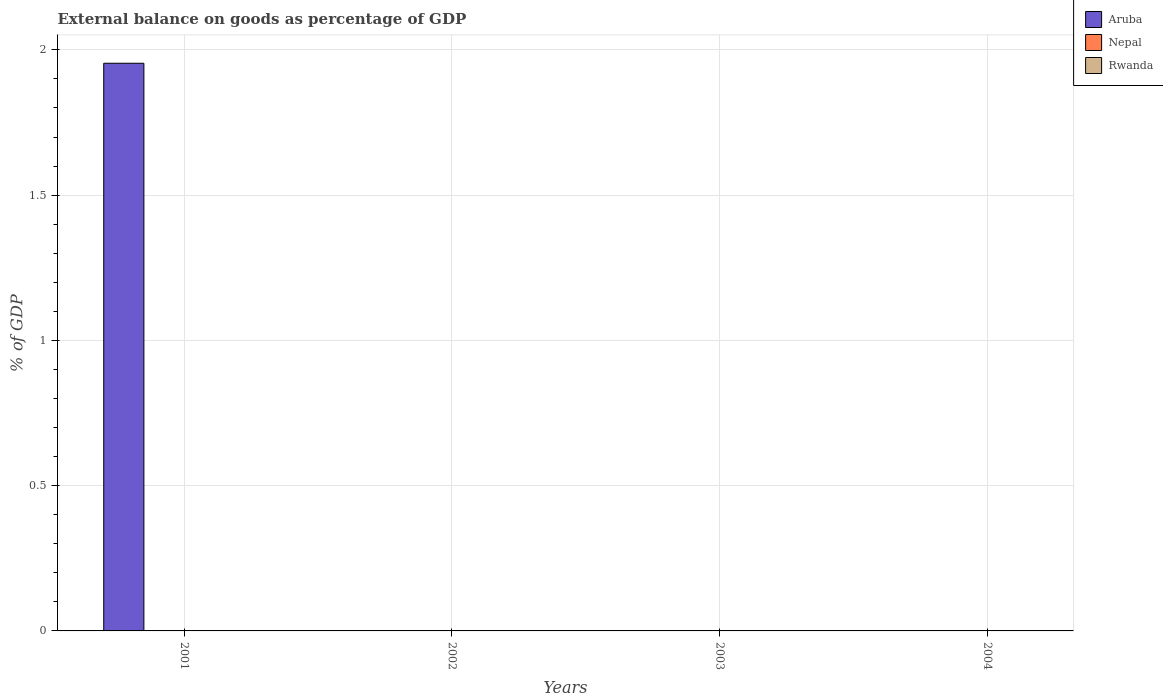How many different coloured bars are there?
Provide a succinct answer. 1. Are the number of bars on each tick of the X-axis equal?
Ensure brevity in your answer.  No. What is the label of the 1st group of bars from the left?
Give a very brief answer. 2001. What is the external balance on goods as percentage of GDP in Aruba in 2004?
Your answer should be compact. 0. Across all years, what is the maximum external balance on goods as percentage of GDP in Aruba?
Provide a short and direct response. 1.95. Across all years, what is the minimum external balance on goods as percentage of GDP in Aruba?
Give a very brief answer. 0. What is the average external balance on goods as percentage of GDP in Aruba per year?
Offer a terse response. 0.49. In how many years, is the external balance on goods as percentage of GDP in Rwanda greater than 0.6 %?
Keep it short and to the point. 0. What is the difference between the highest and the lowest external balance on goods as percentage of GDP in Aruba?
Keep it short and to the point. 1.95. In how many years, is the external balance on goods as percentage of GDP in Aruba greater than the average external balance on goods as percentage of GDP in Aruba taken over all years?
Keep it short and to the point. 1. How many bars are there?
Offer a terse response. 1. Are all the bars in the graph horizontal?
Your answer should be compact. No. What is the difference between two consecutive major ticks on the Y-axis?
Your response must be concise. 0.5. Are the values on the major ticks of Y-axis written in scientific E-notation?
Ensure brevity in your answer.  No. Does the graph contain any zero values?
Offer a very short reply. Yes. Where does the legend appear in the graph?
Offer a very short reply. Top right. How many legend labels are there?
Offer a very short reply. 3. What is the title of the graph?
Keep it short and to the point. External balance on goods as percentage of GDP. What is the label or title of the X-axis?
Ensure brevity in your answer.  Years. What is the label or title of the Y-axis?
Your answer should be very brief. % of GDP. What is the % of GDP in Aruba in 2001?
Make the answer very short. 1.95. What is the % of GDP of Nepal in 2001?
Your answer should be compact. 0. What is the % of GDP in Rwanda in 2001?
Offer a terse response. 0. What is the % of GDP of Nepal in 2003?
Keep it short and to the point. 0. What is the % of GDP in Nepal in 2004?
Offer a very short reply. 0. Across all years, what is the maximum % of GDP of Aruba?
Ensure brevity in your answer.  1.95. Across all years, what is the minimum % of GDP in Aruba?
Your response must be concise. 0. What is the total % of GDP of Aruba in the graph?
Make the answer very short. 1.95. What is the average % of GDP of Aruba per year?
Provide a succinct answer. 0.49. What is the average % of GDP in Nepal per year?
Your answer should be very brief. 0. What is the difference between the highest and the lowest % of GDP in Aruba?
Ensure brevity in your answer.  1.95. 